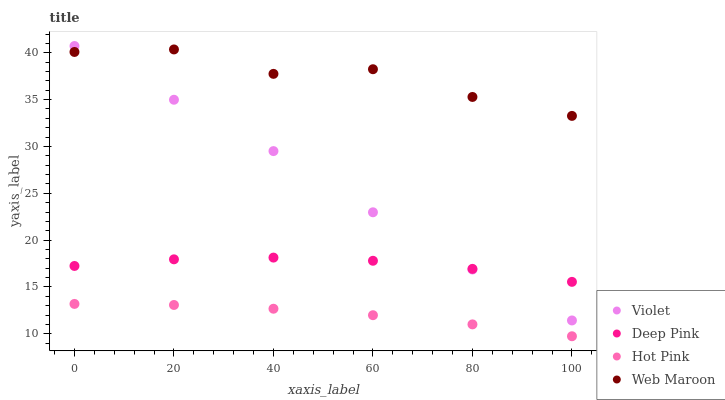Does Hot Pink have the minimum area under the curve?
Answer yes or no. Yes. Does Web Maroon have the maximum area under the curve?
Answer yes or no. Yes. Does Deep Pink have the minimum area under the curve?
Answer yes or no. No. Does Deep Pink have the maximum area under the curve?
Answer yes or no. No. Is Hot Pink the smoothest?
Answer yes or no. Yes. Is Web Maroon the roughest?
Answer yes or no. Yes. Is Deep Pink the smoothest?
Answer yes or no. No. Is Deep Pink the roughest?
Answer yes or no. No. Does Hot Pink have the lowest value?
Answer yes or no. Yes. Does Deep Pink have the lowest value?
Answer yes or no. No. Does Violet have the highest value?
Answer yes or no. Yes. Does Deep Pink have the highest value?
Answer yes or no. No. Is Hot Pink less than Deep Pink?
Answer yes or no. Yes. Is Web Maroon greater than Deep Pink?
Answer yes or no. Yes. Does Web Maroon intersect Violet?
Answer yes or no. Yes. Is Web Maroon less than Violet?
Answer yes or no. No. Is Web Maroon greater than Violet?
Answer yes or no. No. Does Hot Pink intersect Deep Pink?
Answer yes or no. No. 